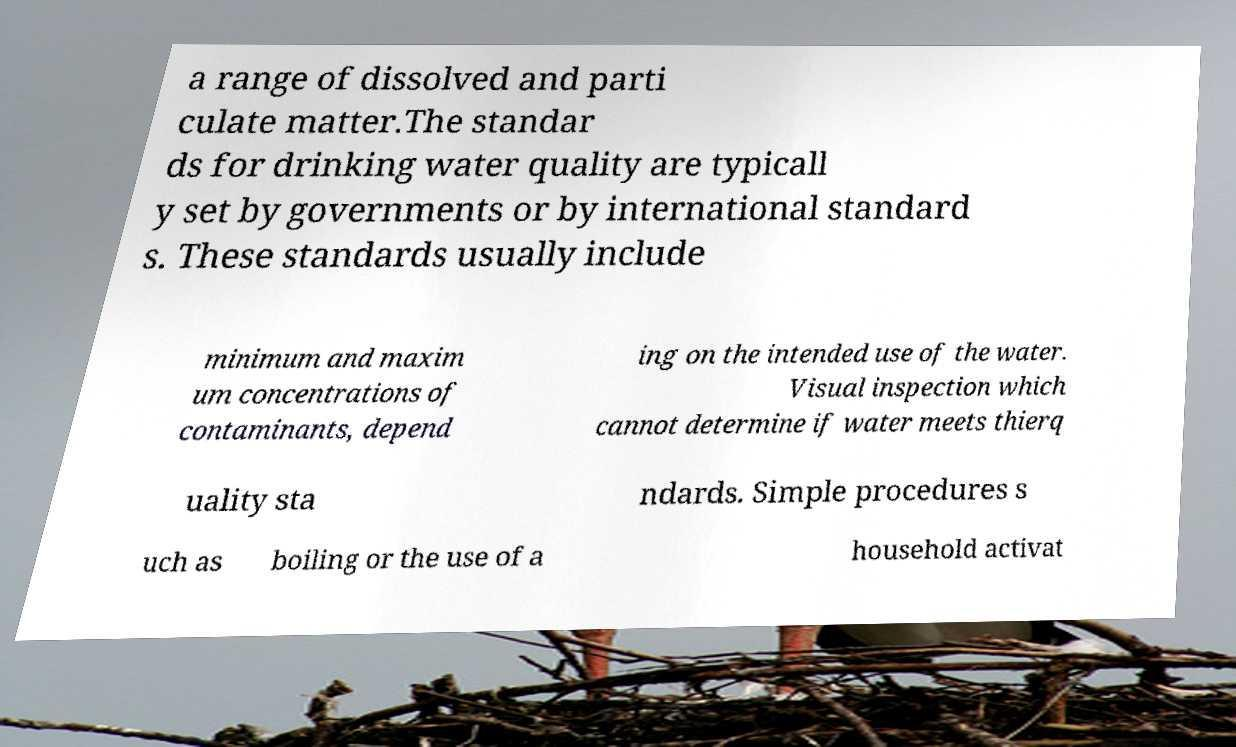Can you accurately transcribe the text from the provided image for me? a range of dissolved and parti culate matter.The standar ds for drinking water quality are typicall y set by governments or by international standard s. These standards usually include minimum and maxim um concentrations of contaminants, depend ing on the intended use of the water. Visual inspection which cannot determine if water meets thierq uality sta ndards. Simple procedures s uch as boiling or the use of a household activat 